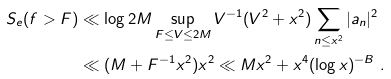<formula> <loc_0><loc_0><loc_500><loc_500>S _ { e } ( f > F ) & \ll \log 2 M \sup _ { F \leq V \leq 2 M } V ^ { - 1 } ( V ^ { 2 } + x ^ { 2 } ) \sum _ { n \leq x ^ { 2 } } | a _ { n } | ^ { 2 } \\ & \ll ( M + F ^ { - 1 } x ^ { 2 } ) x ^ { 2 } \ll M x ^ { 2 } + x ^ { 4 } ( \log x ) ^ { - B } \ .</formula> 